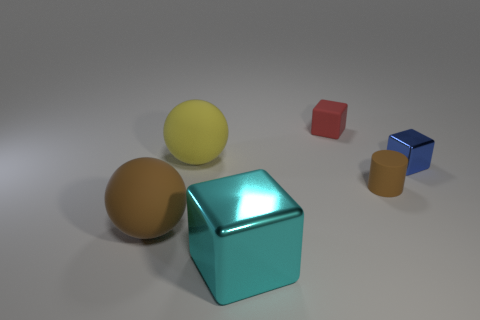What size is the blue thing that is the same shape as the cyan object?
Your answer should be very brief. Small. The thing that is both on the left side of the rubber block and right of the big yellow ball is made of what material?
Provide a succinct answer. Metal. Are there the same number of small red cubes that are to the left of the red rubber block and small red blocks?
Ensure brevity in your answer.  No. What number of objects are large blocks right of the yellow matte sphere or tiny objects?
Offer a terse response. 4. There is a large rubber ball that is in front of the blue metal thing; does it have the same color as the small metal thing?
Your answer should be compact. No. What size is the brown cylinder that is in front of the blue shiny object?
Ensure brevity in your answer.  Small. The brown thing right of the shiny cube left of the tiny red block is what shape?
Make the answer very short. Cylinder. There is another tiny thing that is the same shape as the blue thing; what is its color?
Make the answer very short. Red. Is the size of the matte thing in front of the cylinder the same as the tiny red thing?
Offer a terse response. No. There is a big rubber object that is the same color as the small cylinder; what is its shape?
Give a very brief answer. Sphere. 